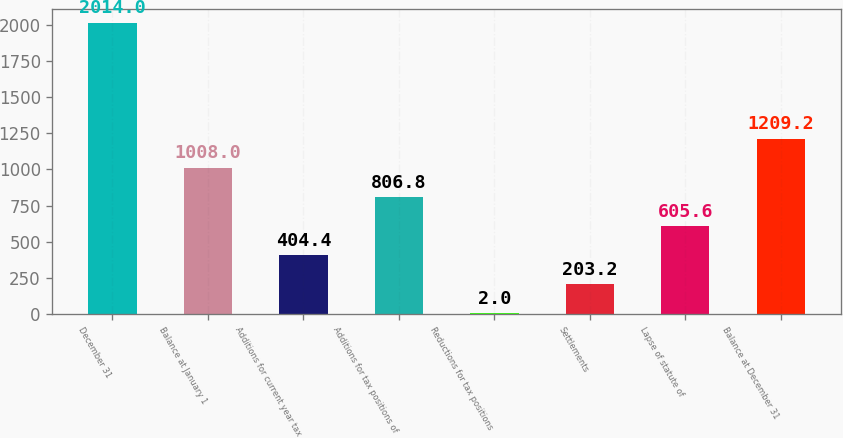<chart> <loc_0><loc_0><loc_500><loc_500><bar_chart><fcel>December 31<fcel>Balance at January 1<fcel>Additions for current year tax<fcel>Additions for tax positions of<fcel>Reductions for tax positions<fcel>Settlements<fcel>Lapse of statute of<fcel>Balance at December 31<nl><fcel>2014<fcel>1008<fcel>404.4<fcel>806.8<fcel>2<fcel>203.2<fcel>605.6<fcel>1209.2<nl></chart> 